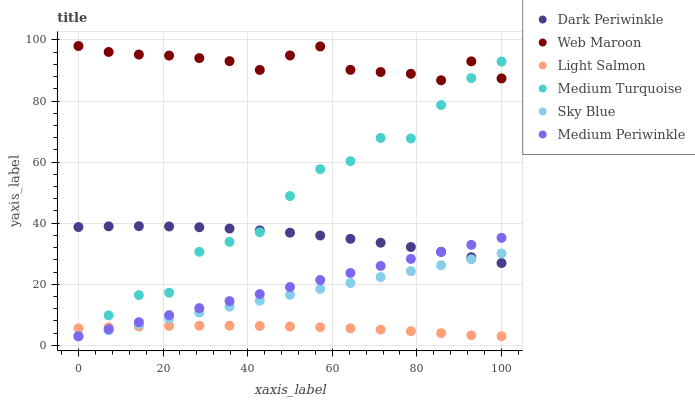Does Light Salmon have the minimum area under the curve?
Answer yes or no. Yes. Does Web Maroon have the maximum area under the curve?
Answer yes or no. Yes. Does Medium Periwinkle have the minimum area under the curve?
Answer yes or no. No. Does Medium Periwinkle have the maximum area under the curve?
Answer yes or no. No. Is Sky Blue the smoothest?
Answer yes or no. Yes. Is Medium Turquoise the roughest?
Answer yes or no. Yes. Is Medium Periwinkle the smoothest?
Answer yes or no. No. Is Medium Periwinkle the roughest?
Answer yes or no. No. Does Light Salmon have the lowest value?
Answer yes or no. Yes. Does Web Maroon have the lowest value?
Answer yes or no. No. Does Web Maroon have the highest value?
Answer yes or no. Yes. Does Medium Periwinkle have the highest value?
Answer yes or no. No. Is Sky Blue less than Web Maroon?
Answer yes or no. Yes. Is Web Maroon greater than Medium Periwinkle?
Answer yes or no. Yes. Does Sky Blue intersect Medium Turquoise?
Answer yes or no. Yes. Is Sky Blue less than Medium Turquoise?
Answer yes or no. No. Is Sky Blue greater than Medium Turquoise?
Answer yes or no. No. Does Sky Blue intersect Web Maroon?
Answer yes or no. No. 